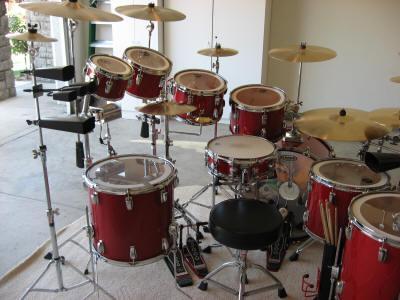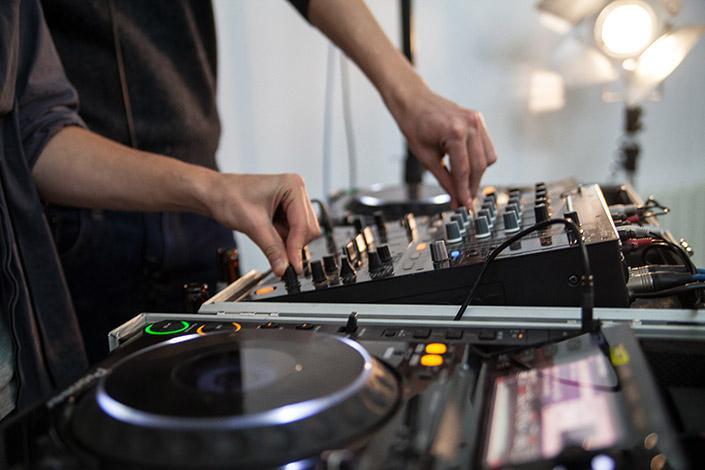The first image is the image on the left, the second image is the image on the right. Evaluate the accuracy of this statement regarding the images: "At least one human is playing an instrument.". Is it true? Answer yes or no. Yes. The first image is the image on the left, the second image is the image on the right. Analyze the images presented: Is the assertion "Each image contains a drum kit with multiple cymbals and cylindrical drums, but no image shows someone playing the drums." valid? Answer yes or no. No. 